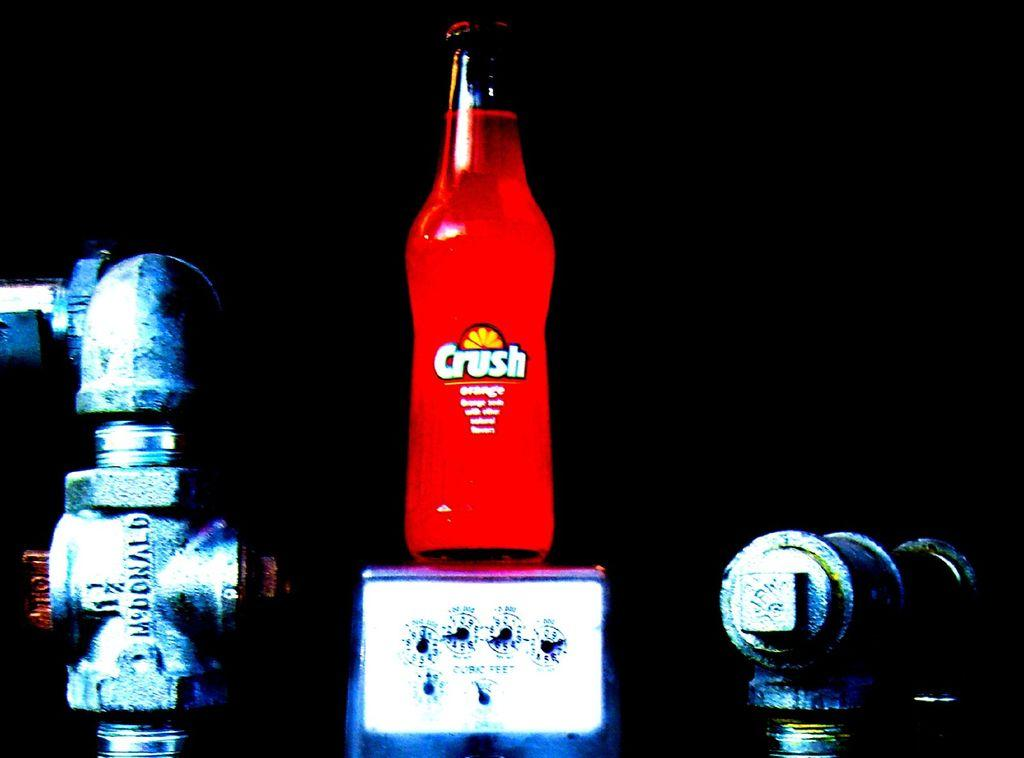<image>
Give a short and clear explanation of the subsequent image. A bottle of red Crush soda sitting on a scale with metal tools beside the scale. 